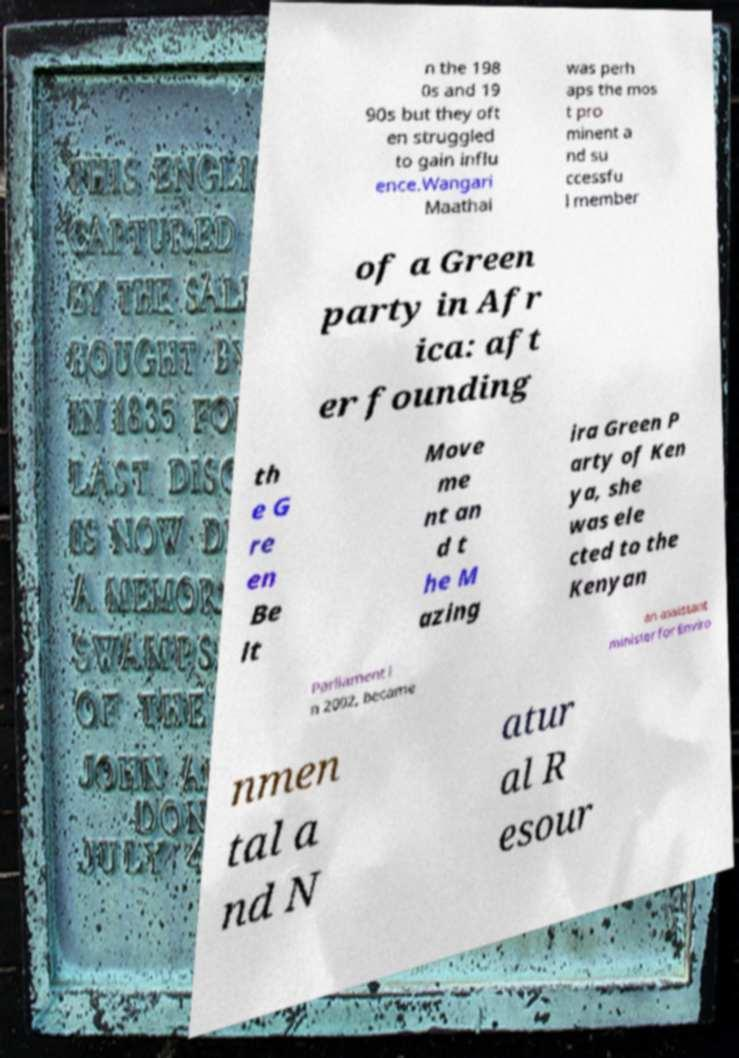Please identify and transcribe the text found in this image. n the 198 0s and 19 90s but they oft en struggled to gain influ ence.Wangari Maathai was perh aps the mos t pro minent a nd su ccessfu l member of a Green party in Afr ica: aft er founding th e G re en Be lt Move me nt an d t he M azing ira Green P arty of Ken ya, she was ele cted to the Kenyan Parliament i n 2002, became an assistant minister for Enviro nmen tal a nd N atur al R esour 